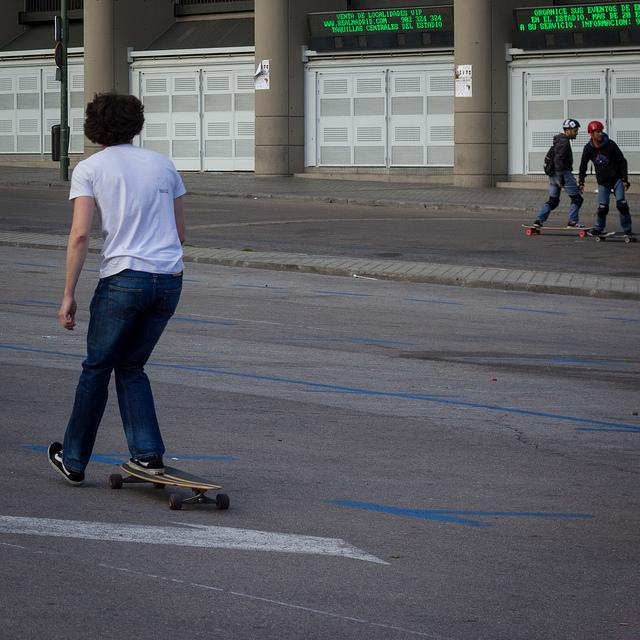What style of skateboard is the man in the white shirt using? Please explain your reasoning. long board. The board is not a traditional skateboard. it looks like an older "longboard" design from decades past. 